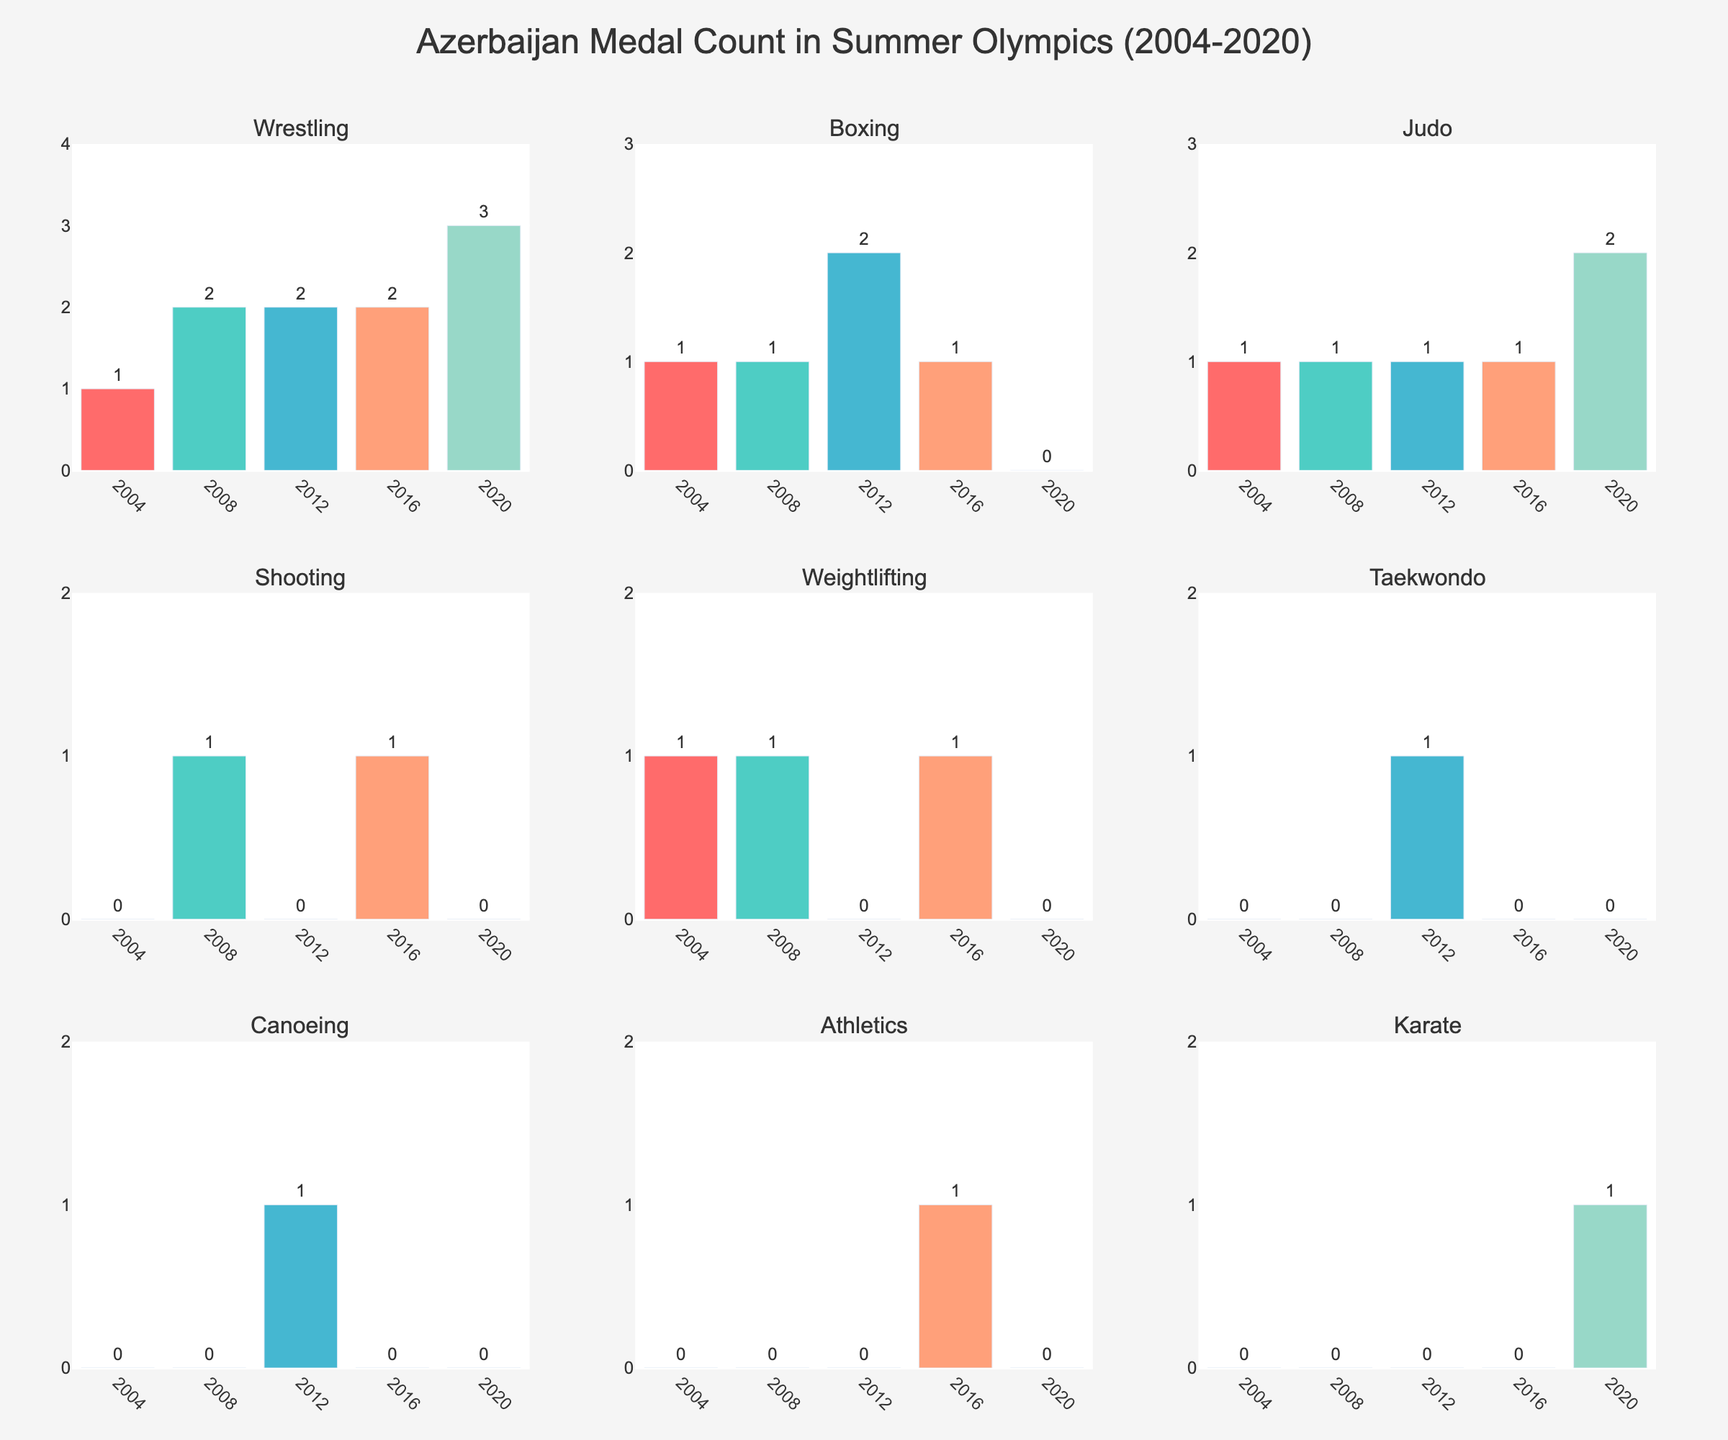What's the title of the figure? The title of the figure is usually positioned at the top center of the chart and provides a summary of what the chart represents.
Answer: Azerbaijan Medal Count in Summer Olympics (2004-2020) How many sports are represented in the figure? The subplot titles are different sports, each having its own mini chart. Counting the titles gives the number of sports.
Answer: 9 Which sport has the highest number of medals in 2020? Look at the bar height for each sport in the 2020 category; the tallest bar indicates the highest number of medals.
Answer: Wrestling Which sport saw the highest increase in medals from 2016 to 2020? Compare the bar heights of each sport between the years 2016 and 2020. Subtract the 2016 value from the 2020 value for each sport and identify the sport with the highest difference.
Answer: Judo In how many Olympics did Azerbaijan win medals in Judo? Check the bars for the sport Judo across all the years and count the years in which there's a bar greater than zero.
Answer: 5 What's the total number of medals Azerbaijan won in Wrestling across all five Olympics? Add the values of the Wrestling bars from all five years (2004, 2008, 2012, 2016, 2020).
Answer: 10 Which sport has zero medals in 2020? Look at the bars for 2020 and identify the sport with a zero-height bar.
Answer: Boxing, Shooting, Weightlifting, Taekwondo, Canoeing, Athletics Did the number of medals in Boxing increase, decrease, or stay the same from 2004 to 2008? Compare the bar heights for Boxing in 2004 and 2008 to determine the trend. If 2008 is taller, it increased; if shorter, it decreased; if the same height, it stayed the same.
Answer: Stayed the same What's the difference in the number of medals between Shooting and Judo in 2008? Subtract the number of medals in Shooting in 2008 from the number of medals in Judo in the same year.
Answer: 0 Which sport won medals only once in the last five Olympics? Look for sports with only one bar greater than zero across all five years.
Answer: Karate 